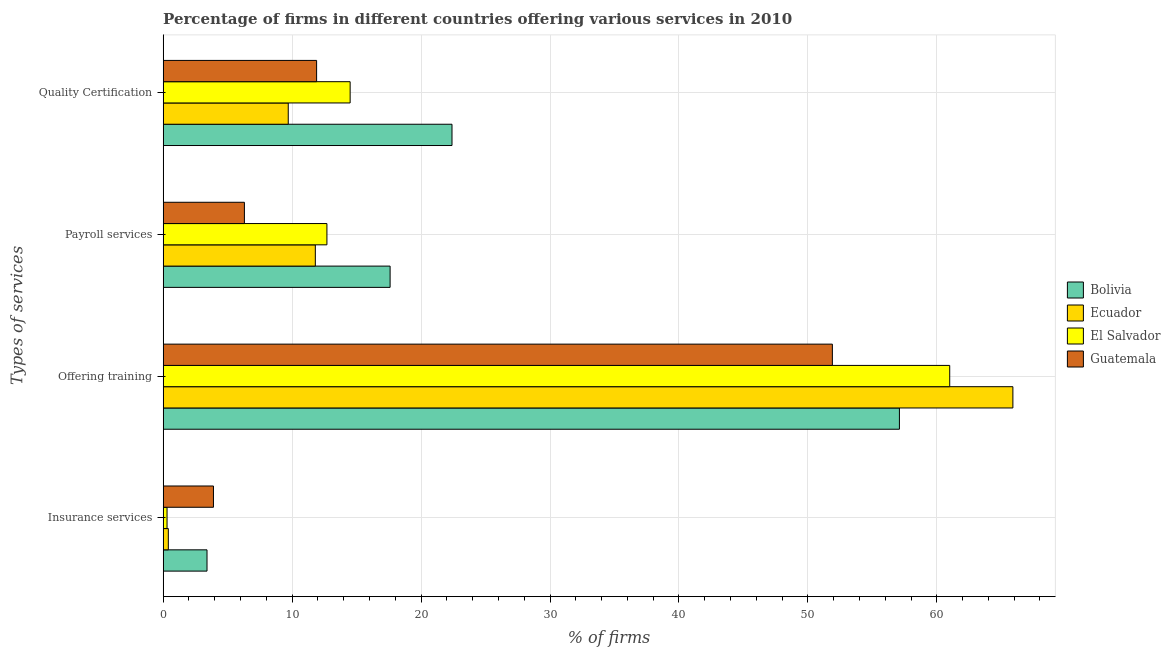How many different coloured bars are there?
Give a very brief answer. 4. Are the number of bars per tick equal to the number of legend labels?
Provide a succinct answer. Yes. How many bars are there on the 2nd tick from the top?
Offer a very short reply. 4. What is the label of the 4th group of bars from the top?
Ensure brevity in your answer.  Insurance services. Across all countries, what is the maximum percentage of firms offering quality certification?
Ensure brevity in your answer.  22.4. Across all countries, what is the minimum percentage of firms offering payroll services?
Offer a terse response. 6.3. In which country was the percentage of firms offering training minimum?
Your answer should be very brief. Guatemala. What is the total percentage of firms offering quality certification in the graph?
Offer a very short reply. 58.5. What is the difference between the percentage of firms offering payroll services in Ecuador and the percentage of firms offering quality certification in El Salvador?
Your answer should be compact. -2.7. What is the difference between the percentage of firms offering insurance services and percentage of firms offering payroll services in Bolivia?
Your answer should be very brief. -14.2. In how many countries, is the percentage of firms offering quality certification greater than 22 %?
Your response must be concise. 1. What is the ratio of the percentage of firms offering quality certification in Guatemala to that in Bolivia?
Make the answer very short. 0.53. Is the difference between the percentage of firms offering payroll services in Bolivia and El Salvador greater than the difference between the percentage of firms offering training in Bolivia and El Salvador?
Make the answer very short. Yes. What is the difference between the highest and the second highest percentage of firms offering payroll services?
Provide a succinct answer. 4.9. Is the sum of the percentage of firms offering quality certification in Guatemala and Bolivia greater than the maximum percentage of firms offering insurance services across all countries?
Keep it short and to the point. Yes. What does the 4th bar from the bottom in Payroll services represents?
Your answer should be very brief. Guatemala. What is the difference between two consecutive major ticks on the X-axis?
Your response must be concise. 10. Are the values on the major ticks of X-axis written in scientific E-notation?
Ensure brevity in your answer.  No. Does the graph contain any zero values?
Your answer should be very brief. No. Does the graph contain grids?
Give a very brief answer. Yes. Where does the legend appear in the graph?
Your response must be concise. Center right. What is the title of the graph?
Your response must be concise. Percentage of firms in different countries offering various services in 2010. Does "Guinea" appear as one of the legend labels in the graph?
Your answer should be very brief. No. What is the label or title of the X-axis?
Your response must be concise. % of firms. What is the label or title of the Y-axis?
Ensure brevity in your answer.  Types of services. What is the % of firms in Bolivia in Insurance services?
Offer a terse response. 3.4. What is the % of firms in Bolivia in Offering training?
Offer a very short reply. 57.1. What is the % of firms in Ecuador in Offering training?
Provide a succinct answer. 65.9. What is the % of firms in El Salvador in Offering training?
Ensure brevity in your answer.  61. What is the % of firms in Guatemala in Offering training?
Give a very brief answer. 51.9. What is the % of firms of Bolivia in Payroll services?
Keep it short and to the point. 17.6. What is the % of firms in El Salvador in Payroll services?
Your answer should be compact. 12.7. What is the % of firms in Bolivia in Quality Certification?
Ensure brevity in your answer.  22.4. What is the % of firms in Ecuador in Quality Certification?
Your response must be concise. 9.7. What is the % of firms in El Salvador in Quality Certification?
Keep it short and to the point. 14.5. Across all Types of services, what is the maximum % of firms of Bolivia?
Keep it short and to the point. 57.1. Across all Types of services, what is the maximum % of firms in Ecuador?
Your answer should be compact. 65.9. Across all Types of services, what is the maximum % of firms in El Salvador?
Provide a succinct answer. 61. Across all Types of services, what is the maximum % of firms in Guatemala?
Ensure brevity in your answer.  51.9. Across all Types of services, what is the minimum % of firms of El Salvador?
Provide a short and direct response. 0.3. Across all Types of services, what is the minimum % of firms in Guatemala?
Make the answer very short. 3.9. What is the total % of firms in Bolivia in the graph?
Your response must be concise. 100.5. What is the total % of firms in Ecuador in the graph?
Provide a short and direct response. 87.8. What is the total % of firms in El Salvador in the graph?
Give a very brief answer. 88.5. What is the difference between the % of firms of Bolivia in Insurance services and that in Offering training?
Your answer should be compact. -53.7. What is the difference between the % of firms in Ecuador in Insurance services and that in Offering training?
Keep it short and to the point. -65.5. What is the difference between the % of firms in El Salvador in Insurance services and that in Offering training?
Give a very brief answer. -60.7. What is the difference between the % of firms in Guatemala in Insurance services and that in Offering training?
Provide a short and direct response. -48. What is the difference between the % of firms of Ecuador in Insurance services and that in Payroll services?
Your answer should be very brief. -11.4. What is the difference between the % of firms in Guatemala in Insurance services and that in Payroll services?
Provide a succinct answer. -2.4. What is the difference between the % of firms in Ecuador in Insurance services and that in Quality Certification?
Provide a succinct answer. -9.3. What is the difference between the % of firms in Guatemala in Insurance services and that in Quality Certification?
Keep it short and to the point. -8. What is the difference between the % of firms in Bolivia in Offering training and that in Payroll services?
Give a very brief answer. 39.5. What is the difference between the % of firms of Ecuador in Offering training and that in Payroll services?
Provide a short and direct response. 54.1. What is the difference between the % of firms in El Salvador in Offering training and that in Payroll services?
Offer a very short reply. 48.3. What is the difference between the % of firms of Guatemala in Offering training and that in Payroll services?
Make the answer very short. 45.6. What is the difference between the % of firms in Bolivia in Offering training and that in Quality Certification?
Offer a very short reply. 34.7. What is the difference between the % of firms in Ecuador in Offering training and that in Quality Certification?
Your response must be concise. 56.2. What is the difference between the % of firms of El Salvador in Offering training and that in Quality Certification?
Your answer should be very brief. 46.5. What is the difference between the % of firms in Guatemala in Offering training and that in Quality Certification?
Offer a very short reply. 40. What is the difference between the % of firms in Ecuador in Payroll services and that in Quality Certification?
Provide a short and direct response. 2.1. What is the difference between the % of firms in El Salvador in Payroll services and that in Quality Certification?
Offer a terse response. -1.8. What is the difference between the % of firms of Bolivia in Insurance services and the % of firms of Ecuador in Offering training?
Your answer should be very brief. -62.5. What is the difference between the % of firms of Bolivia in Insurance services and the % of firms of El Salvador in Offering training?
Your response must be concise. -57.6. What is the difference between the % of firms in Bolivia in Insurance services and the % of firms in Guatemala in Offering training?
Your response must be concise. -48.5. What is the difference between the % of firms of Ecuador in Insurance services and the % of firms of El Salvador in Offering training?
Your answer should be very brief. -60.6. What is the difference between the % of firms of Ecuador in Insurance services and the % of firms of Guatemala in Offering training?
Your answer should be very brief. -51.5. What is the difference between the % of firms of El Salvador in Insurance services and the % of firms of Guatemala in Offering training?
Make the answer very short. -51.6. What is the difference between the % of firms in Bolivia in Insurance services and the % of firms in Ecuador in Payroll services?
Your answer should be compact. -8.4. What is the difference between the % of firms in Ecuador in Insurance services and the % of firms in El Salvador in Payroll services?
Provide a short and direct response. -12.3. What is the difference between the % of firms of Ecuador in Insurance services and the % of firms of Guatemala in Payroll services?
Offer a terse response. -5.9. What is the difference between the % of firms of El Salvador in Insurance services and the % of firms of Guatemala in Payroll services?
Your response must be concise. -6. What is the difference between the % of firms of Ecuador in Insurance services and the % of firms of El Salvador in Quality Certification?
Your answer should be very brief. -14.1. What is the difference between the % of firms of El Salvador in Insurance services and the % of firms of Guatemala in Quality Certification?
Give a very brief answer. -11.6. What is the difference between the % of firms of Bolivia in Offering training and the % of firms of Ecuador in Payroll services?
Keep it short and to the point. 45.3. What is the difference between the % of firms of Bolivia in Offering training and the % of firms of El Salvador in Payroll services?
Provide a succinct answer. 44.4. What is the difference between the % of firms of Bolivia in Offering training and the % of firms of Guatemala in Payroll services?
Your answer should be compact. 50.8. What is the difference between the % of firms of Ecuador in Offering training and the % of firms of El Salvador in Payroll services?
Your answer should be very brief. 53.2. What is the difference between the % of firms in Ecuador in Offering training and the % of firms in Guatemala in Payroll services?
Your answer should be compact. 59.6. What is the difference between the % of firms of El Salvador in Offering training and the % of firms of Guatemala in Payroll services?
Your response must be concise. 54.7. What is the difference between the % of firms of Bolivia in Offering training and the % of firms of Ecuador in Quality Certification?
Give a very brief answer. 47.4. What is the difference between the % of firms of Bolivia in Offering training and the % of firms of El Salvador in Quality Certification?
Ensure brevity in your answer.  42.6. What is the difference between the % of firms in Bolivia in Offering training and the % of firms in Guatemala in Quality Certification?
Make the answer very short. 45.2. What is the difference between the % of firms in Ecuador in Offering training and the % of firms in El Salvador in Quality Certification?
Give a very brief answer. 51.4. What is the difference between the % of firms of Ecuador in Offering training and the % of firms of Guatemala in Quality Certification?
Your answer should be compact. 54. What is the difference between the % of firms in El Salvador in Offering training and the % of firms in Guatemala in Quality Certification?
Your answer should be compact. 49.1. What is the difference between the % of firms in Bolivia in Payroll services and the % of firms in Ecuador in Quality Certification?
Offer a terse response. 7.9. What is the difference between the % of firms in Bolivia in Payroll services and the % of firms in El Salvador in Quality Certification?
Your answer should be compact. 3.1. What is the difference between the % of firms in Ecuador in Payroll services and the % of firms in El Salvador in Quality Certification?
Ensure brevity in your answer.  -2.7. What is the difference between the % of firms in El Salvador in Payroll services and the % of firms in Guatemala in Quality Certification?
Keep it short and to the point. 0.8. What is the average % of firms in Bolivia per Types of services?
Give a very brief answer. 25.12. What is the average % of firms of Ecuador per Types of services?
Provide a succinct answer. 21.95. What is the average % of firms in El Salvador per Types of services?
Ensure brevity in your answer.  22.12. What is the difference between the % of firms in Bolivia and % of firms in Guatemala in Insurance services?
Provide a succinct answer. -0.5. What is the difference between the % of firms of Ecuador and % of firms of El Salvador in Insurance services?
Your answer should be very brief. 0.1. What is the difference between the % of firms in Ecuador and % of firms in Guatemala in Insurance services?
Your answer should be very brief. -3.5. What is the difference between the % of firms of El Salvador and % of firms of Guatemala in Insurance services?
Offer a terse response. -3.6. What is the difference between the % of firms in Bolivia and % of firms in El Salvador in Offering training?
Offer a terse response. -3.9. What is the difference between the % of firms of Bolivia and % of firms of Guatemala in Offering training?
Your response must be concise. 5.2. What is the difference between the % of firms in Bolivia and % of firms in Ecuador in Payroll services?
Ensure brevity in your answer.  5.8. What is the difference between the % of firms in Bolivia and % of firms in El Salvador in Payroll services?
Your answer should be compact. 4.9. What is the difference between the % of firms in Ecuador and % of firms in Guatemala in Payroll services?
Provide a short and direct response. 5.5. What is the difference between the % of firms of Bolivia and % of firms of Ecuador in Quality Certification?
Offer a terse response. 12.7. What is the ratio of the % of firms of Bolivia in Insurance services to that in Offering training?
Keep it short and to the point. 0.06. What is the ratio of the % of firms of Ecuador in Insurance services to that in Offering training?
Make the answer very short. 0.01. What is the ratio of the % of firms of El Salvador in Insurance services to that in Offering training?
Offer a very short reply. 0. What is the ratio of the % of firms in Guatemala in Insurance services to that in Offering training?
Offer a terse response. 0.08. What is the ratio of the % of firms in Bolivia in Insurance services to that in Payroll services?
Offer a terse response. 0.19. What is the ratio of the % of firms of Ecuador in Insurance services to that in Payroll services?
Your answer should be very brief. 0.03. What is the ratio of the % of firms of El Salvador in Insurance services to that in Payroll services?
Provide a short and direct response. 0.02. What is the ratio of the % of firms of Guatemala in Insurance services to that in Payroll services?
Your answer should be compact. 0.62. What is the ratio of the % of firms of Bolivia in Insurance services to that in Quality Certification?
Your response must be concise. 0.15. What is the ratio of the % of firms in Ecuador in Insurance services to that in Quality Certification?
Give a very brief answer. 0.04. What is the ratio of the % of firms of El Salvador in Insurance services to that in Quality Certification?
Ensure brevity in your answer.  0.02. What is the ratio of the % of firms in Guatemala in Insurance services to that in Quality Certification?
Your response must be concise. 0.33. What is the ratio of the % of firms in Bolivia in Offering training to that in Payroll services?
Your response must be concise. 3.24. What is the ratio of the % of firms of Ecuador in Offering training to that in Payroll services?
Ensure brevity in your answer.  5.58. What is the ratio of the % of firms of El Salvador in Offering training to that in Payroll services?
Provide a succinct answer. 4.8. What is the ratio of the % of firms of Guatemala in Offering training to that in Payroll services?
Keep it short and to the point. 8.24. What is the ratio of the % of firms in Bolivia in Offering training to that in Quality Certification?
Provide a short and direct response. 2.55. What is the ratio of the % of firms of Ecuador in Offering training to that in Quality Certification?
Offer a terse response. 6.79. What is the ratio of the % of firms in El Salvador in Offering training to that in Quality Certification?
Offer a very short reply. 4.21. What is the ratio of the % of firms of Guatemala in Offering training to that in Quality Certification?
Your response must be concise. 4.36. What is the ratio of the % of firms of Bolivia in Payroll services to that in Quality Certification?
Provide a short and direct response. 0.79. What is the ratio of the % of firms in Ecuador in Payroll services to that in Quality Certification?
Offer a very short reply. 1.22. What is the ratio of the % of firms in El Salvador in Payroll services to that in Quality Certification?
Provide a short and direct response. 0.88. What is the ratio of the % of firms in Guatemala in Payroll services to that in Quality Certification?
Your answer should be compact. 0.53. What is the difference between the highest and the second highest % of firms in Bolivia?
Make the answer very short. 34.7. What is the difference between the highest and the second highest % of firms of Ecuador?
Offer a very short reply. 54.1. What is the difference between the highest and the second highest % of firms in El Salvador?
Offer a very short reply. 46.5. What is the difference between the highest and the second highest % of firms in Guatemala?
Offer a very short reply. 40. What is the difference between the highest and the lowest % of firms of Bolivia?
Offer a terse response. 53.7. What is the difference between the highest and the lowest % of firms of Ecuador?
Provide a short and direct response. 65.5. What is the difference between the highest and the lowest % of firms in El Salvador?
Offer a very short reply. 60.7. 